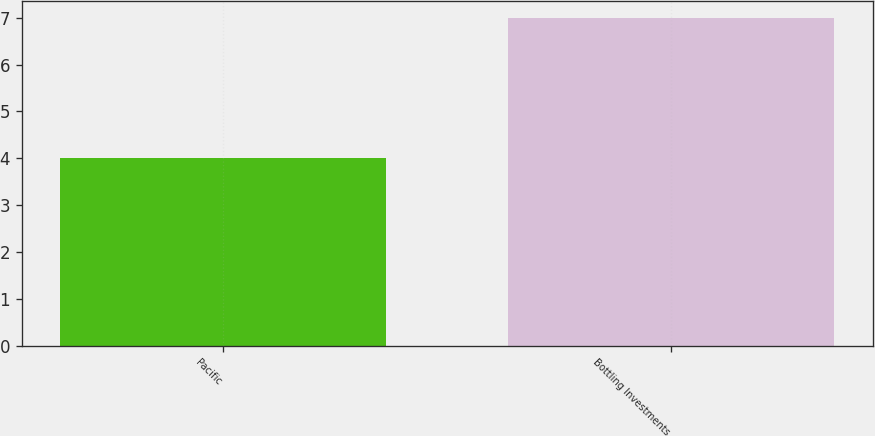<chart> <loc_0><loc_0><loc_500><loc_500><bar_chart><fcel>Pacific<fcel>Bottling Investments<nl><fcel>4<fcel>7<nl></chart> 